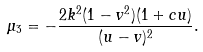<formula> <loc_0><loc_0><loc_500><loc_500>\mu _ { 3 } = - \frac { 2 k ^ { 2 } ( 1 - v ^ { 2 } ) ( 1 + c u ) } { ( u - v ) ^ { 2 } } .</formula> 